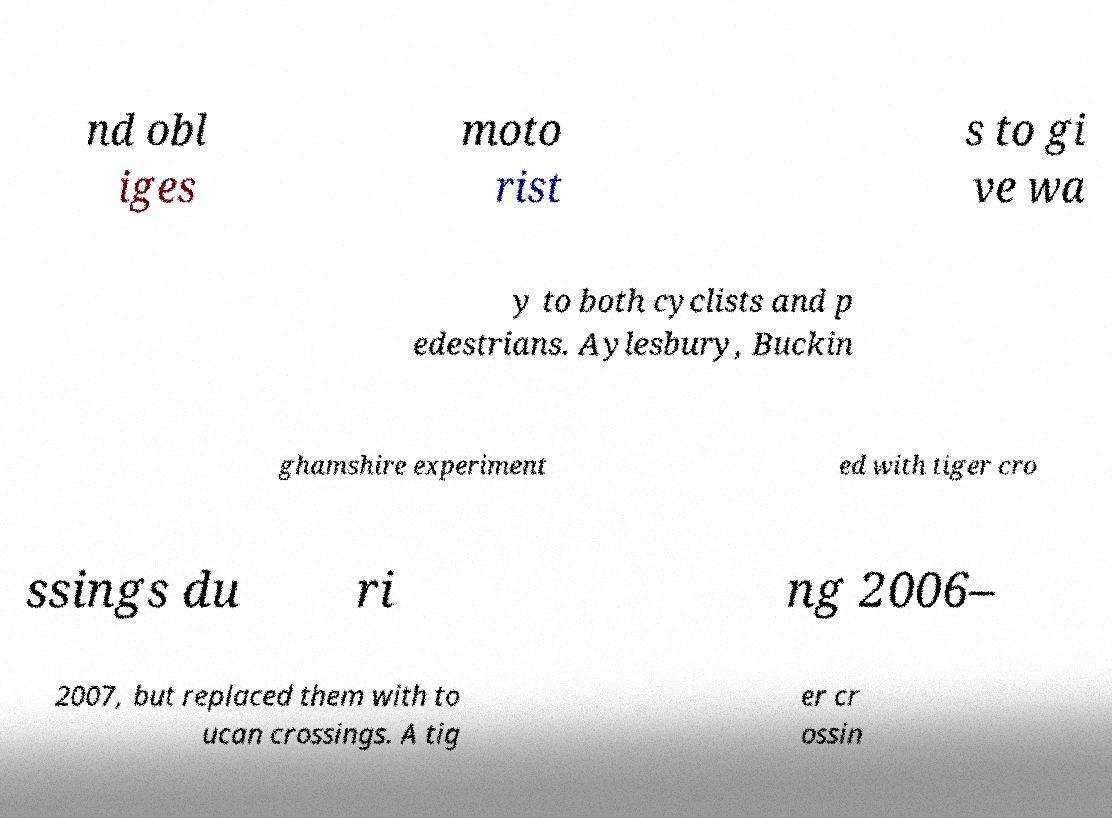For documentation purposes, I need the text within this image transcribed. Could you provide that? nd obl iges moto rist s to gi ve wa y to both cyclists and p edestrians. Aylesbury, Buckin ghamshire experiment ed with tiger cro ssings du ri ng 2006– 2007, but replaced them with to ucan crossings. A tig er cr ossin 